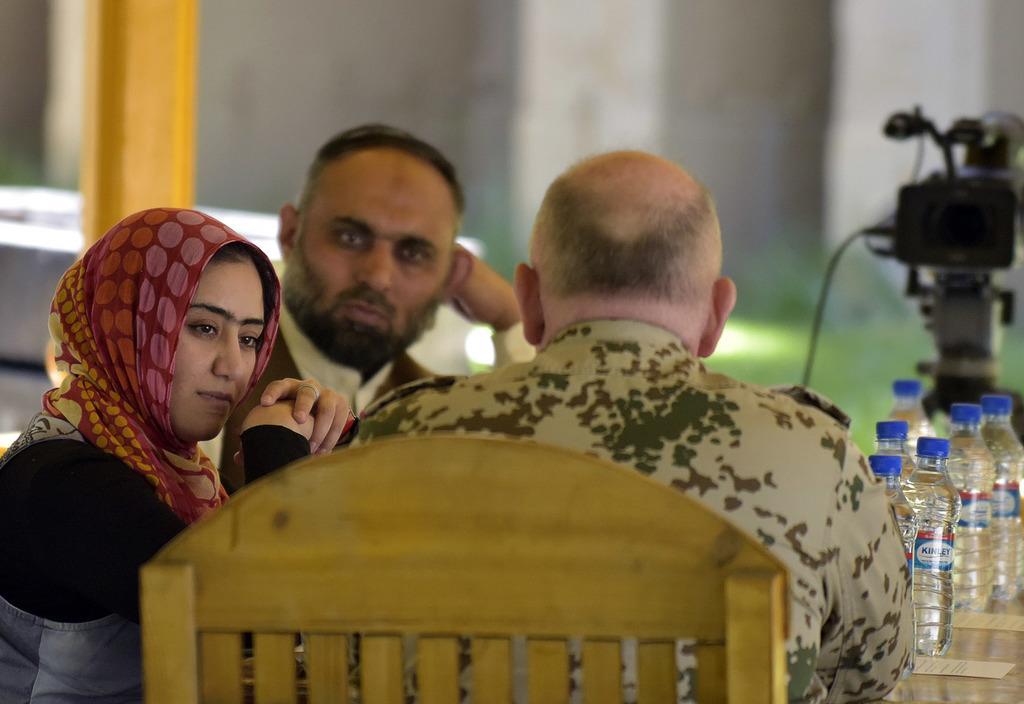How would you summarize this image in a sentence or two? This picture is taken inside the room. In this image, on the left side, we can see two people man and woman are sitting on the chair in front of the table. In the middle of the image, we can see a man sitting on the chair in front of the table, on that table, we can see few water bottles. In the background, we can see a camera and a glass window. 